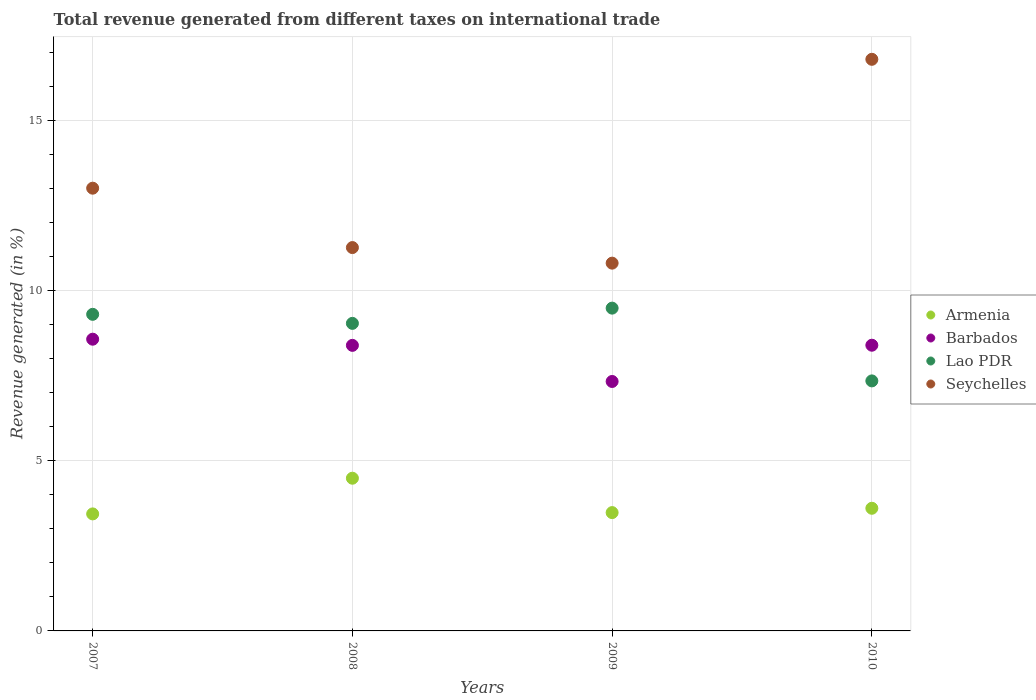Is the number of dotlines equal to the number of legend labels?
Your answer should be very brief. Yes. What is the total revenue generated in Lao PDR in 2009?
Offer a very short reply. 9.48. Across all years, what is the maximum total revenue generated in Barbados?
Provide a short and direct response. 8.57. Across all years, what is the minimum total revenue generated in Armenia?
Provide a succinct answer. 3.44. In which year was the total revenue generated in Lao PDR maximum?
Provide a short and direct response. 2009. What is the total total revenue generated in Barbados in the graph?
Ensure brevity in your answer.  32.68. What is the difference between the total revenue generated in Armenia in 2007 and that in 2009?
Give a very brief answer. -0.04. What is the difference between the total revenue generated in Seychelles in 2009 and the total revenue generated in Barbados in 2008?
Offer a terse response. 2.42. What is the average total revenue generated in Barbados per year?
Offer a very short reply. 8.17. In the year 2010, what is the difference between the total revenue generated in Armenia and total revenue generated in Seychelles?
Your answer should be compact. -13.19. What is the ratio of the total revenue generated in Armenia in 2009 to that in 2010?
Your answer should be compact. 0.96. Is the total revenue generated in Armenia in 2009 less than that in 2010?
Make the answer very short. Yes. What is the difference between the highest and the second highest total revenue generated in Barbados?
Offer a very short reply. 0.18. What is the difference between the highest and the lowest total revenue generated in Seychelles?
Your answer should be very brief. 5.99. In how many years, is the total revenue generated in Seychelles greater than the average total revenue generated in Seychelles taken over all years?
Give a very brief answer. 2. Is the sum of the total revenue generated in Barbados in 2007 and 2009 greater than the maximum total revenue generated in Seychelles across all years?
Keep it short and to the point. No. Is it the case that in every year, the sum of the total revenue generated in Seychelles and total revenue generated in Armenia  is greater than the sum of total revenue generated in Lao PDR and total revenue generated in Barbados?
Give a very brief answer. No. Does the total revenue generated in Armenia monotonically increase over the years?
Offer a very short reply. No. Is the total revenue generated in Armenia strictly greater than the total revenue generated in Lao PDR over the years?
Provide a short and direct response. No. How many dotlines are there?
Your response must be concise. 4. Are the values on the major ticks of Y-axis written in scientific E-notation?
Make the answer very short. No. Does the graph contain grids?
Offer a very short reply. Yes. What is the title of the graph?
Your answer should be compact. Total revenue generated from different taxes on international trade. What is the label or title of the X-axis?
Keep it short and to the point. Years. What is the label or title of the Y-axis?
Offer a very short reply. Revenue generated (in %). What is the Revenue generated (in %) in Armenia in 2007?
Your answer should be very brief. 3.44. What is the Revenue generated (in %) of Barbados in 2007?
Provide a short and direct response. 8.57. What is the Revenue generated (in %) of Lao PDR in 2007?
Your response must be concise. 9.3. What is the Revenue generated (in %) of Seychelles in 2007?
Offer a very short reply. 13.01. What is the Revenue generated (in %) of Armenia in 2008?
Provide a short and direct response. 4.49. What is the Revenue generated (in %) in Barbados in 2008?
Your answer should be very brief. 8.39. What is the Revenue generated (in %) in Lao PDR in 2008?
Make the answer very short. 9.04. What is the Revenue generated (in %) of Seychelles in 2008?
Give a very brief answer. 11.26. What is the Revenue generated (in %) in Armenia in 2009?
Your answer should be compact. 3.48. What is the Revenue generated (in %) in Barbados in 2009?
Provide a short and direct response. 7.33. What is the Revenue generated (in %) of Lao PDR in 2009?
Your answer should be very brief. 9.48. What is the Revenue generated (in %) in Seychelles in 2009?
Your answer should be compact. 10.8. What is the Revenue generated (in %) in Armenia in 2010?
Give a very brief answer. 3.6. What is the Revenue generated (in %) in Barbados in 2010?
Keep it short and to the point. 8.39. What is the Revenue generated (in %) of Lao PDR in 2010?
Your answer should be very brief. 7.34. What is the Revenue generated (in %) of Seychelles in 2010?
Offer a very short reply. 16.79. Across all years, what is the maximum Revenue generated (in %) in Armenia?
Provide a short and direct response. 4.49. Across all years, what is the maximum Revenue generated (in %) in Barbados?
Offer a terse response. 8.57. Across all years, what is the maximum Revenue generated (in %) in Lao PDR?
Offer a very short reply. 9.48. Across all years, what is the maximum Revenue generated (in %) of Seychelles?
Offer a very short reply. 16.79. Across all years, what is the minimum Revenue generated (in %) in Armenia?
Your response must be concise. 3.44. Across all years, what is the minimum Revenue generated (in %) in Barbados?
Provide a short and direct response. 7.33. Across all years, what is the minimum Revenue generated (in %) in Lao PDR?
Give a very brief answer. 7.34. Across all years, what is the minimum Revenue generated (in %) in Seychelles?
Offer a very short reply. 10.8. What is the total Revenue generated (in %) of Armenia in the graph?
Offer a very short reply. 15. What is the total Revenue generated (in %) of Barbados in the graph?
Your answer should be compact. 32.68. What is the total Revenue generated (in %) of Lao PDR in the graph?
Provide a short and direct response. 35.16. What is the total Revenue generated (in %) in Seychelles in the graph?
Your answer should be very brief. 51.86. What is the difference between the Revenue generated (in %) of Armenia in 2007 and that in 2008?
Ensure brevity in your answer.  -1.05. What is the difference between the Revenue generated (in %) in Barbados in 2007 and that in 2008?
Offer a very short reply. 0.18. What is the difference between the Revenue generated (in %) in Lao PDR in 2007 and that in 2008?
Your answer should be compact. 0.27. What is the difference between the Revenue generated (in %) in Seychelles in 2007 and that in 2008?
Your response must be concise. 1.74. What is the difference between the Revenue generated (in %) in Armenia in 2007 and that in 2009?
Offer a terse response. -0.04. What is the difference between the Revenue generated (in %) of Barbados in 2007 and that in 2009?
Give a very brief answer. 1.24. What is the difference between the Revenue generated (in %) in Lao PDR in 2007 and that in 2009?
Your answer should be compact. -0.18. What is the difference between the Revenue generated (in %) in Seychelles in 2007 and that in 2009?
Your answer should be compact. 2.2. What is the difference between the Revenue generated (in %) of Armenia in 2007 and that in 2010?
Provide a succinct answer. -0.17. What is the difference between the Revenue generated (in %) of Barbados in 2007 and that in 2010?
Give a very brief answer. 0.18. What is the difference between the Revenue generated (in %) of Lao PDR in 2007 and that in 2010?
Offer a very short reply. 1.96. What is the difference between the Revenue generated (in %) in Seychelles in 2007 and that in 2010?
Make the answer very short. -3.79. What is the difference between the Revenue generated (in %) in Armenia in 2008 and that in 2009?
Offer a terse response. 1.01. What is the difference between the Revenue generated (in %) of Barbados in 2008 and that in 2009?
Ensure brevity in your answer.  1.06. What is the difference between the Revenue generated (in %) of Lao PDR in 2008 and that in 2009?
Provide a succinct answer. -0.45. What is the difference between the Revenue generated (in %) of Seychelles in 2008 and that in 2009?
Your response must be concise. 0.46. What is the difference between the Revenue generated (in %) in Armenia in 2008 and that in 2010?
Give a very brief answer. 0.88. What is the difference between the Revenue generated (in %) in Barbados in 2008 and that in 2010?
Your response must be concise. -0. What is the difference between the Revenue generated (in %) in Lao PDR in 2008 and that in 2010?
Your answer should be compact. 1.69. What is the difference between the Revenue generated (in %) of Seychelles in 2008 and that in 2010?
Your response must be concise. -5.53. What is the difference between the Revenue generated (in %) of Armenia in 2009 and that in 2010?
Offer a terse response. -0.13. What is the difference between the Revenue generated (in %) of Barbados in 2009 and that in 2010?
Keep it short and to the point. -1.06. What is the difference between the Revenue generated (in %) in Lao PDR in 2009 and that in 2010?
Make the answer very short. 2.14. What is the difference between the Revenue generated (in %) in Seychelles in 2009 and that in 2010?
Keep it short and to the point. -5.99. What is the difference between the Revenue generated (in %) of Armenia in 2007 and the Revenue generated (in %) of Barbados in 2008?
Offer a terse response. -4.95. What is the difference between the Revenue generated (in %) of Armenia in 2007 and the Revenue generated (in %) of Lao PDR in 2008?
Ensure brevity in your answer.  -5.6. What is the difference between the Revenue generated (in %) in Armenia in 2007 and the Revenue generated (in %) in Seychelles in 2008?
Make the answer very short. -7.82. What is the difference between the Revenue generated (in %) in Barbados in 2007 and the Revenue generated (in %) in Lao PDR in 2008?
Your answer should be compact. -0.47. What is the difference between the Revenue generated (in %) in Barbados in 2007 and the Revenue generated (in %) in Seychelles in 2008?
Your answer should be compact. -2.69. What is the difference between the Revenue generated (in %) of Lao PDR in 2007 and the Revenue generated (in %) of Seychelles in 2008?
Provide a succinct answer. -1.96. What is the difference between the Revenue generated (in %) of Armenia in 2007 and the Revenue generated (in %) of Barbados in 2009?
Offer a very short reply. -3.89. What is the difference between the Revenue generated (in %) of Armenia in 2007 and the Revenue generated (in %) of Lao PDR in 2009?
Keep it short and to the point. -6.04. What is the difference between the Revenue generated (in %) in Armenia in 2007 and the Revenue generated (in %) in Seychelles in 2009?
Provide a succinct answer. -7.37. What is the difference between the Revenue generated (in %) in Barbados in 2007 and the Revenue generated (in %) in Lao PDR in 2009?
Offer a terse response. -0.91. What is the difference between the Revenue generated (in %) of Barbados in 2007 and the Revenue generated (in %) of Seychelles in 2009?
Your response must be concise. -2.23. What is the difference between the Revenue generated (in %) of Lao PDR in 2007 and the Revenue generated (in %) of Seychelles in 2009?
Offer a terse response. -1.5. What is the difference between the Revenue generated (in %) in Armenia in 2007 and the Revenue generated (in %) in Barbados in 2010?
Your answer should be very brief. -4.96. What is the difference between the Revenue generated (in %) of Armenia in 2007 and the Revenue generated (in %) of Lao PDR in 2010?
Make the answer very short. -3.91. What is the difference between the Revenue generated (in %) of Armenia in 2007 and the Revenue generated (in %) of Seychelles in 2010?
Offer a very short reply. -13.35. What is the difference between the Revenue generated (in %) of Barbados in 2007 and the Revenue generated (in %) of Lao PDR in 2010?
Offer a very short reply. 1.23. What is the difference between the Revenue generated (in %) in Barbados in 2007 and the Revenue generated (in %) in Seychelles in 2010?
Make the answer very short. -8.22. What is the difference between the Revenue generated (in %) of Lao PDR in 2007 and the Revenue generated (in %) of Seychelles in 2010?
Your answer should be compact. -7.49. What is the difference between the Revenue generated (in %) in Armenia in 2008 and the Revenue generated (in %) in Barbados in 2009?
Your response must be concise. -2.84. What is the difference between the Revenue generated (in %) in Armenia in 2008 and the Revenue generated (in %) in Lao PDR in 2009?
Your response must be concise. -5. What is the difference between the Revenue generated (in %) of Armenia in 2008 and the Revenue generated (in %) of Seychelles in 2009?
Ensure brevity in your answer.  -6.32. What is the difference between the Revenue generated (in %) of Barbados in 2008 and the Revenue generated (in %) of Lao PDR in 2009?
Your answer should be very brief. -1.09. What is the difference between the Revenue generated (in %) in Barbados in 2008 and the Revenue generated (in %) in Seychelles in 2009?
Your answer should be compact. -2.42. What is the difference between the Revenue generated (in %) in Lao PDR in 2008 and the Revenue generated (in %) in Seychelles in 2009?
Offer a terse response. -1.77. What is the difference between the Revenue generated (in %) of Armenia in 2008 and the Revenue generated (in %) of Barbados in 2010?
Provide a short and direct response. -3.91. What is the difference between the Revenue generated (in %) in Armenia in 2008 and the Revenue generated (in %) in Lao PDR in 2010?
Offer a very short reply. -2.86. What is the difference between the Revenue generated (in %) in Armenia in 2008 and the Revenue generated (in %) in Seychelles in 2010?
Offer a terse response. -12.31. What is the difference between the Revenue generated (in %) of Barbados in 2008 and the Revenue generated (in %) of Lao PDR in 2010?
Provide a succinct answer. 1.04. What is the difference between the Revenue generated (in %) of Barbados in 2008 and the Revenue generated (in %) of Seychelles in 2010?
Offer a very short reply. -8.4. What is the difference between the Revenue generated (in %) of Lao PDR in 2008 and the Revenue generated (in %) of Seychelles in 2010?
Keep it short and to the point. -7.76. What is the difference between the Revenue generated (in %) in Armenia in 2009 and the Revenue generated (in %) in Barbados in 2010?
Provide a succinct answer. -4.92. What is the difference between the Revenue generated (in %) in Armenia in 2009 and the Revenue generated (in %) in Lao PDR in 2010?
Provide a succinct answer. -3.87. What is the difference between the Revenue generated (in %) in Armenia in 2009 and the Revenue generated (in %) in Seychelles in 2010?
Keep it short and to the point. -13.32. What is the difference between the Revenue generated (in %) of Barbados in 2009 and the Revenue generated (in %) of Lao PDR in 2010?
Keep it short and to the point. -0.02. What is the difference between the Revenue generated (in %) in Barbados in 2009 and the Revenue generated (in %) in Seychelles in 2010?
Your answer should be compact. -9.46. What is the difference between the Revenue generated (in %) in Lao PDR in 2009 and the Revenue generated (in %) in Seychelles in 2010?
Ensure brevity in your answer.  -7.31. What is the average Revenue generated (in %) of Armenia per year?
Provide a short and direct response. 3.75. What is the average Revenue generated (in %) in Barbados per year?
Offer a very short reply. 8.17. What is the average Revenue generated (in %) in Lao PDR per year?
Ensure brevity in your answer.  8.79. What is the average Revenue generated (in %) of Seychelles per year?
Your response must be concise. 12.97. In the year 2007, what is the difference between the Revenue generated (in %) in Armenia and Revenue generated (in %) in Barbados?
Your answer should be very brief. -5.13. In the year 2007, what is the difference between the Revenue generated (in %) in Armenia and Revenue generated (in %) in Lao PDR?
Ensure brevity in your answer.  -5.86. In the year 2007, what is the difference between the Revenue generated (in %) in Armenia and Revenue generated (in %) in Seychelles?
Offer a terse response. -9.57. In the year 2007, what is the difference between the Revenue generated (in %) of Barbados and Revenue generated (in %) of Lao PDR?
Make the answer very short. -0.73. In the year 2007, what is the difference between the Revenue generated (in %) of Barbados and Revenue generated (in %) of Seychelles?
Make the answer very short. -4.44. In the year 2007, what is the difference between the Revenue generated (in %) of Lao PDR and Revenue generated (in %) of Seychelles?
Offer a terse response. -3.71. In the year 2008, what is the difference between the Revenue generated (in %) of Armenia and Revenue generated (in %) of Barbados?
Keep it short and to the point. -3.9. In the year 2008, what is the difference between the Revenue generated (in %) in Armenia and Revenue generated (in %) in Lao PDR?
Ensure brevity in your answer.  -4.55. In the year 2008, what is the difference between the Revenue generated (in %) of Armenia and Revenue generated (in %) of Seychelles?
Offer a terse response. -6.78. In the year 2008, what is the difference between the Revenue generated (in %) of Barbados and Revenue generated (in %) of Lao PDR?
Your answer should be very brief. -0.65. In the year 2008, what is the difference between the Revenue generated (in %) of Barbados and Revenue generated (in %) of Seychelles?
Your answer should be compact. -2.87. In the year 2008, what is the difference between the Revenue generated (in %) of Lao PDR and Revenue generated (in %) of Seychelles?
Make the answer very short. -2.23. In the year 2009, what is the difference between the Revenue generated (in %) of Armenia and Revenue generated (in %) of Barbados?
Offer a terse response. -3.85. In the year 2009, what is the difference between the Revenue generated (in %) of Armenia and Revenue generated (in %) of Lao PDR?
Provide a succinct answer. -6.01. In the year 2009, what is the difference between the Revenue generated (in %) of Armenia and Revenue generated (in %) of Seychelles?
Offer a terse response. -7.33. In the year 2009, what is the difference between the Revenue generated (in %) in Barbados and Revenue generated (in %) in Lao PDR?
Keep it short and to the point. -2.15. In the year 2009, what is the difference between the Revenue generated (in %) of Barbados and Revenue generated (in %) of Seychelles?
Offer a very short reply. -3.48. In the year 2009, what is the difference between the Revenue generated (in %) in Lao PDR and Revenue generated (in %) in Seychelles?
Your answer should be very brief. -1.32. In the year 2010, what is the difference between the Revenue generated (in %) in Armenia and Revenue generated (in %) in Barbados?
Your answer should be compact. -4.79. In the year 2010, what is the difference between the Revenue generated (in %) in Armenia and Revenue generated (in %) in Lao PDR?
Provide a succinct answer. -3.74. In the year 2010, what is the difference between the Revenue generated (in %) in Armenia and Revenue generated (in %) in Seychelles?
Make the answer very short. -13.19. In the year 2010, what is the difference between the Revenue generated (in %) in Barbados and Revenue generated (in %) in Lao PDR?
Ensure brevity in your answer.  1.05. In the year 2010, what is the difference between the Revenue generated (in %) in Barbados and Revenue generated (in %) in Seychelles?
Your response must be concise. -8.4. In the year 2010, what is the difference between the Revenue generated (in %) of Lao PDR and Revenue generated (in %) of Seychelles?
Offer a very short reply. -9.45. What is the ratio of the Revenue generated (in %) of Armenia in 2007 to that in 2008?
Provide a short and direct response. 0.77. What is the ratio of the Revenue generated (in %) of Barbados in 2007 to that in 2008?
Your response must be concise. 1.02. What is the ratio of the Revenue generated (in %) in Lao PDR in 2007 to that in 2008?
Your answer should be very brief. 1.03. What is the ratio of the Revenue generated (in %) in Seychelles in 2007 to that in 2008?
Make the answer very short. 1.15. What is the ratio of the Revenue generated (in %) in Barbados in 2007 to that in 2009?
Offer a terse response. 1.17. What is the ratio of the Revenue generated (in %) in Lao PDR in 2007 to that in 2009?
Provide a succinct answer. 0.98. What is the ratio of the Revenue generated (in %) in Seychelles in 2007 to that in 2009?
Make the answer very short. 1.2. What is the ratio of the Revenue generated (in %) of Armenia in 2007 to that in 2010?
Provide a succinct answer. 0.95. What is the ratio of the Revenue generated (in %) of Barbados in 2007 to that in 2010?
Provide a short and direct response. 1.02. What is the ratio of the Revenue generated (in %) of Lao PDR in 2007 to that in 2010?
Make the answer very short. 1.27. What is the ratio of the Revenue generated (in %) of Seychelles in 2007 to that in 2010?
Your answer should be very brief. 0.77. What is the ratio of the Revenue generated (in %) in Armenia in 2008 to that in 2009?
Your response must be concise. 1.29. What is the ratio of the Revenue generated (in %) in Barbados in 2008 to that in 2009?
Provide a succinct answer. 1.14. What is the ratio of the Revenue generated (in %) of Lao PDR in 2008 to that in 2009?
Offer a very short reply. 0.95. What is the ratio of the Revenue generated (in %) in Seychelles in 2008 to that in 2009?
Provide a short and direct response. 1.04. What is the ratio of the Revenue generated (in %) of Armenia in 2008 to that in 2010?
Your answer should be compact. 1.25. What is the ratio of the Revenue generated (in %) of Barbados in 2008 to that in 2010?
Your response must be concise. 1. What is the ratio of the Revenue generated (in %) of Lao PDR in 2008 to that in 2010?
Your answer should be compact. 1.23. What is the ratio of the Revenue generated (in %) of Seychelles in 2008 to that in 2010?
Give a very brief answer. 0.67. What is the ratio of the Revenue generated (in %) of Armenia in 2009 to that in 2010?
Make the answer very short. 0.96. What is the ratio of the Revenue generated (in %) of Barbados in 2009 to that in 2010?
Offer a terse response. 0.87. What is the ratio of the Revenue generated (in %) of Lao PDR in 2009 to that in 2010?
Your response must be concise. 1.29. What is the ratio of the Revenue generated (in %) in Seychelles in 2009 to that in 2010?
Offer a very short reply. 0.64. What is the difference between the highest and the second highest Revenue generated (in %) of Armenia?
Your answer should be very brief. 0.88. What is the difference between the highest and the second highest Revenue generated (in %) in Barbados?
Keep it short and to the point. 0.18. What is the difference between the highest and the second highest Revenue generated (in %) in Lao PDR?
Offer a terse response. 0.18. What is the difference between the highest and the second highest Revenue generated (in %) of Seychelles?
Provide a succinct answer. 3.79. What is the difference between the highest and the lowest Revenue generated (in %) of Armenia?
Provide a succinct answer. 1.05. What is the difference between the highest and the lowest Revenue generated (in %) in Barbados?
Provide a short and direct response. 1.24. What is the difference between the highest and the lowest Revenue generated (in %) in Lao PDR?
Your answer should be very brief. 2.14. What is the difference between the highest and the lowest Revenue generated (in %) in Seychelles?
Provide a succinct answer. 5.99. 